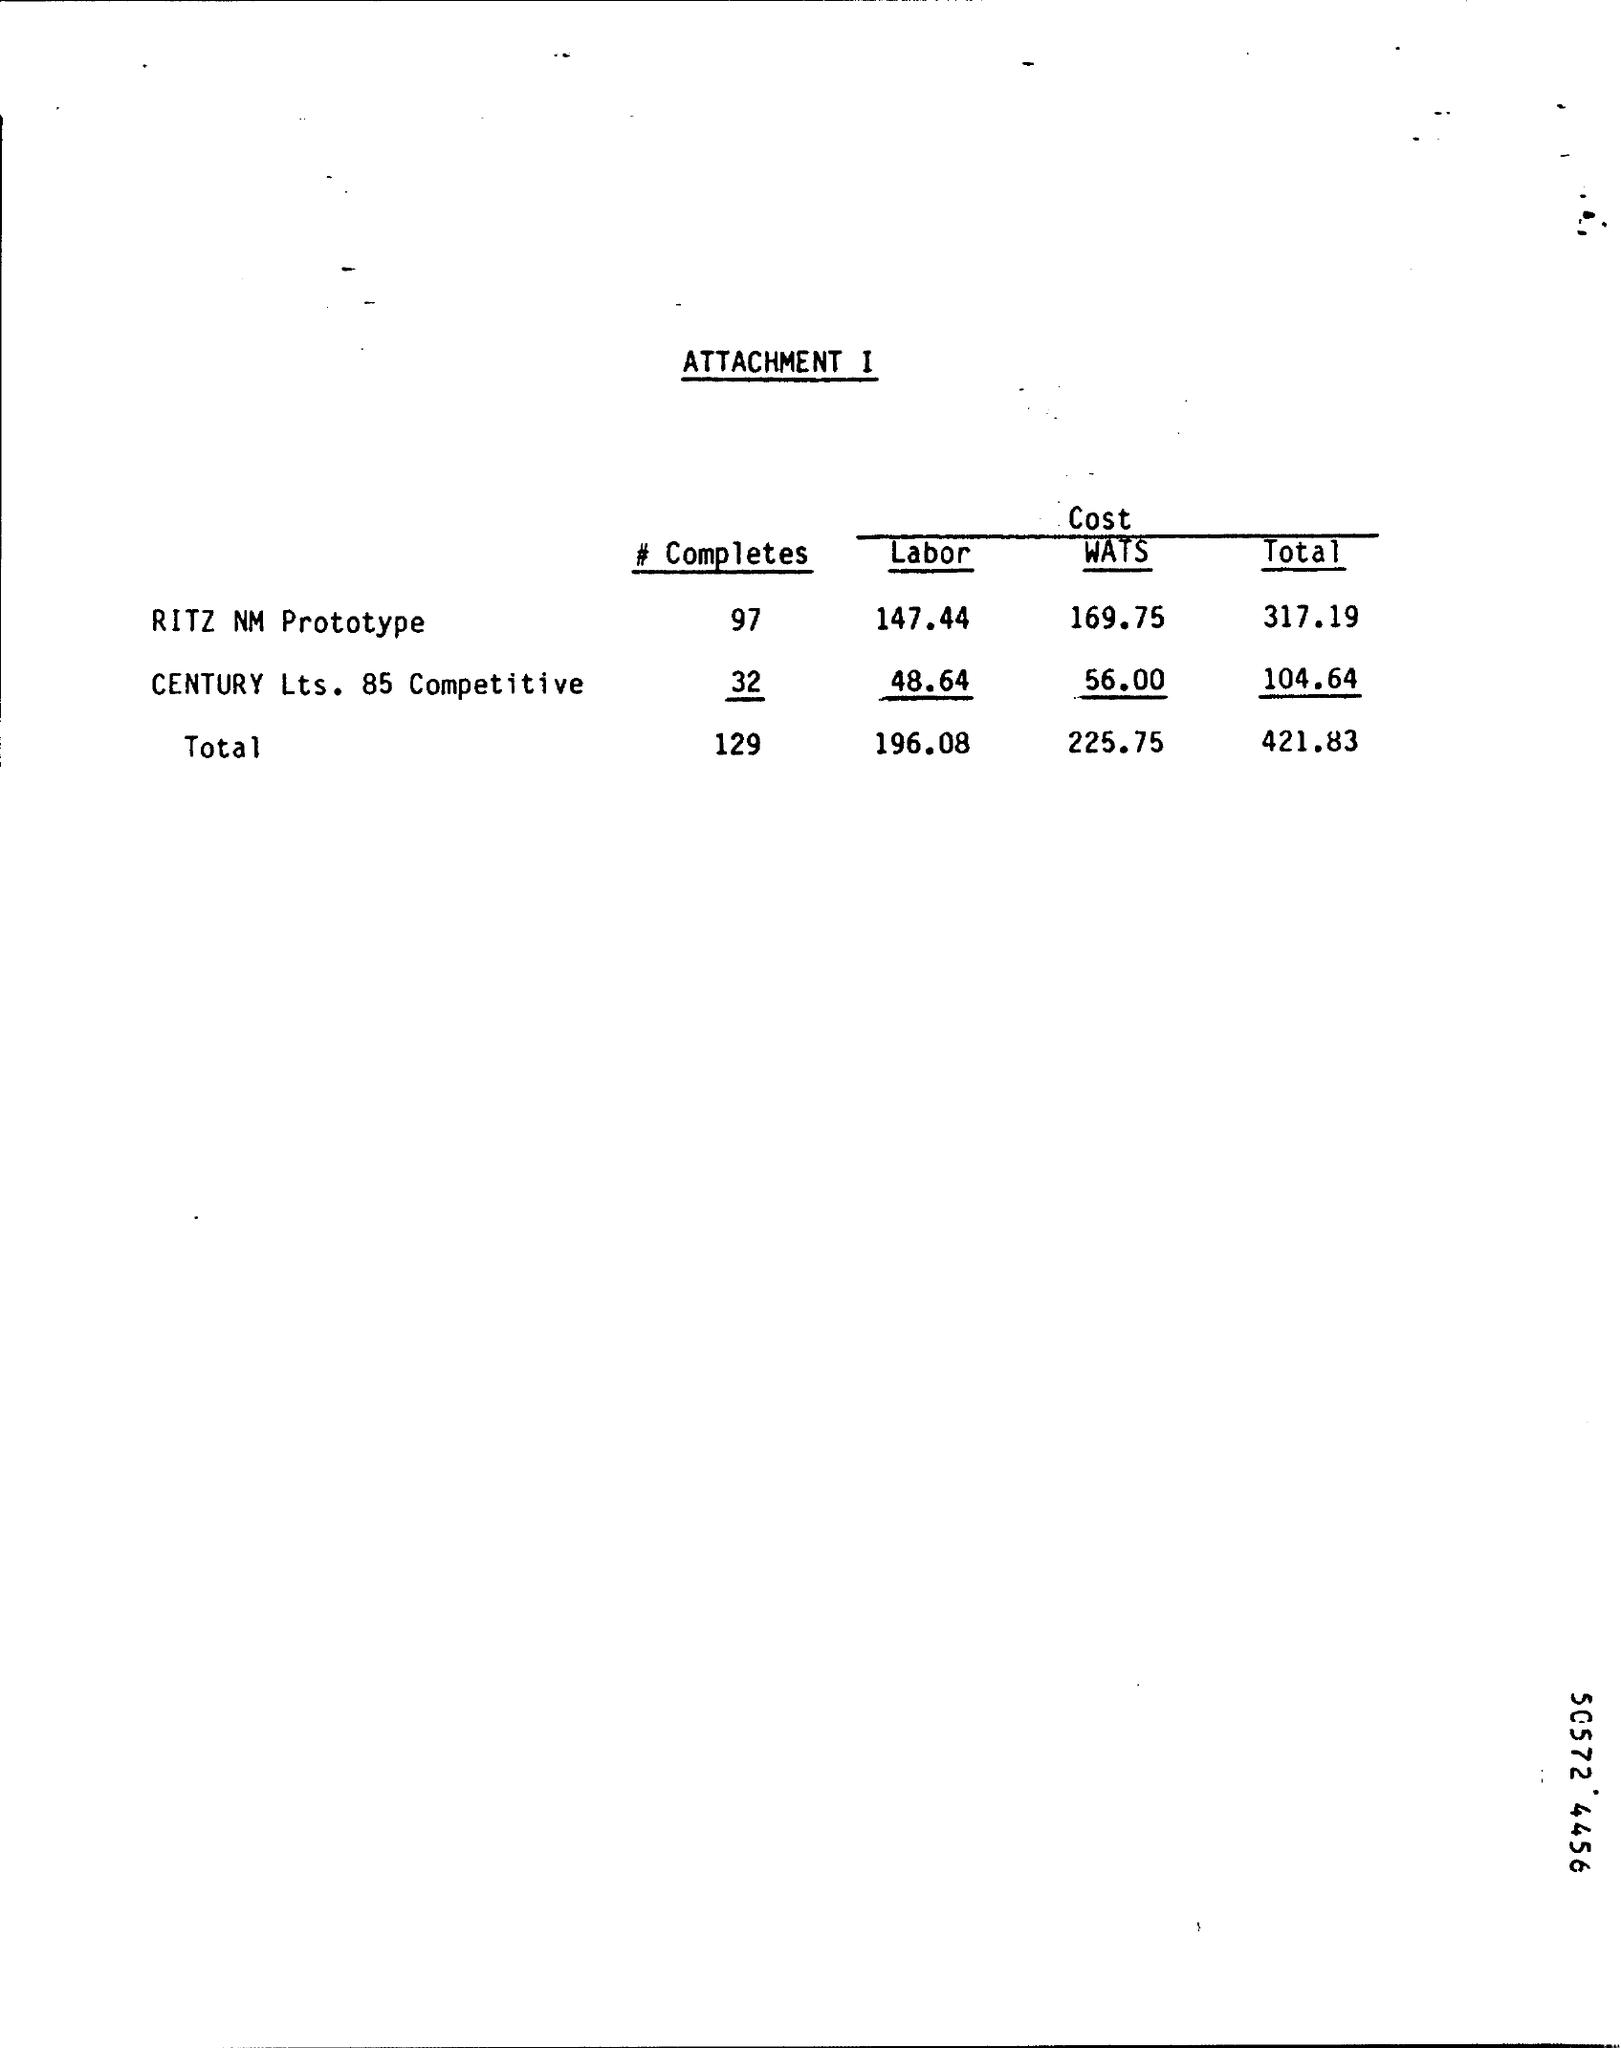How much is the labor cost for RITZ NM Prototype?
Provide a succinct answer. 147.44. How much is the wats cost for ritz nm prototype ?
Offer a terse response. 169.75. How much is the WATS cost for CENTURY Lts. 85 Competitive ?
Give a very brief answer. 56.00. How much is the total cost for RITZ NM Prototype ?
Provide a short and direct response. 317.19. How much is total cost for CENTURY Lts. 85 Competitive ?
Offer a terse response. 104.64. What is the sum total of all the costs?
Give a very brief answer. 421.83. 